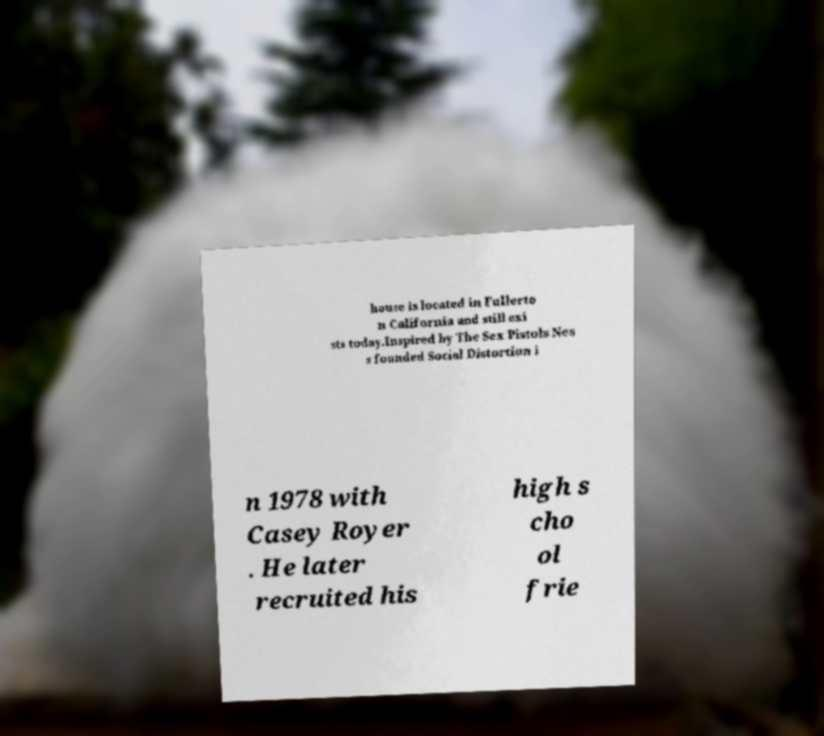For documentation purposes, I need the text within this image transcribed. Could you provide that? house is located in Fullerto n California and still exi sts today.Inspired by The Sex Pistols Nes s founded Social Distortion i n 1978 with Casey Royer . He later recruited his high s cho ol frie 